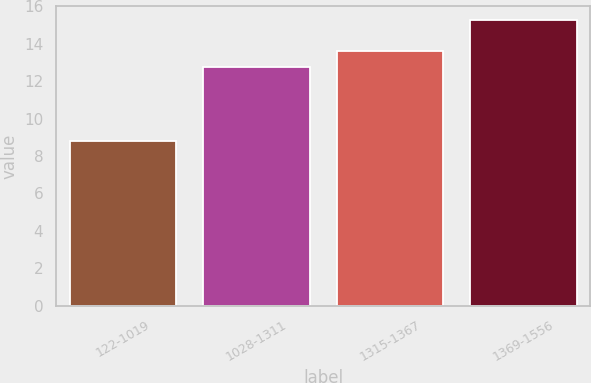Convert chart. <chart><loc_0><loc_0><loc_500><loc_500><bar_chart><fcel>122-1019<fcel>1028-1311<fcel>1315-1367<fcel>1369-1556<nl><fcel>8.78<fcel>12.78<fcel>13.63<fcel>15.25<nl></chart> 